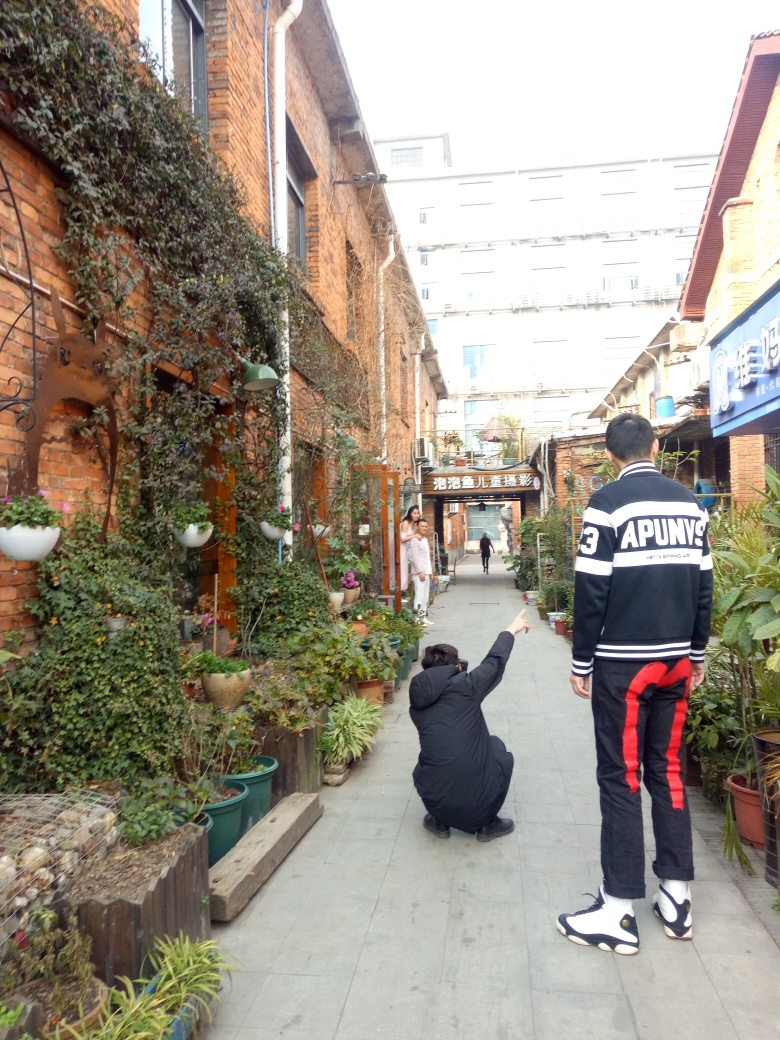Can you tell me more about the setting of this picture? The image captures a charming alley, possibly within an historic or cultural district. The use of traditional brickwork and the abundant greenery suggest a place that values aesthetic appeal and possibly has artistic or cultural significance. Are there any distinctive features that stand out? The brick architecture and potted plants create a distinctive ambiance. Also, the sign hanging overhead possibly indicates the alleyway leads to a specific place, such as a local market, restaurant, or cultural site. 